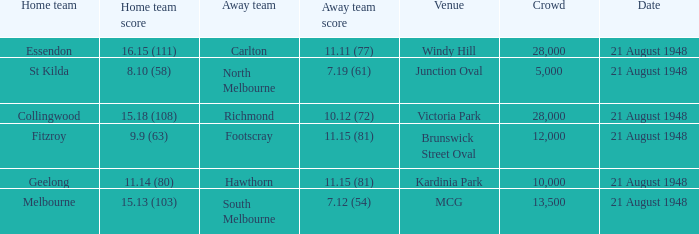When the Home team score was 15.18 (108), what's the lowest Crowd turnout? 28000.0. Parse the table in full. {'header': ['Home team', 'Home team score', 'Away team', 'Away team score', 'Venue', 'Crowd', 'Date'], 'rows': [['Essendon', '16.15 (111)', 'Carlton', '11.11 (77)', 'Windy Hill', '28,000', '21 August 1948'], ['St Kilda', '8.10 (58)', 'North Melbourne', '7.19 (61)', 'Junction Oval', '5,000', '21 August 1948'], ['Collingwood', '15.18 (108)', 'Richmond', '10.12 (72)', 'Victoria Park', '28,000', '21 August 1948'], ['Fitzroy', '9.9 (63)', 'Footscray', '11.15 (81)', 'Brunswick Street Oval', '12,000', '21 August 1948'], ['Geelong', '11.14 (80)', 'Hawthorn', '11.15 (81)', 'Kardinia Park', '10,000', '21 August 1948'], ['Melbourne', '15.13 (103)', 'South Melbourne', '7.12 (54)', 'MCG', '13,500', '21 August 1948']]} 